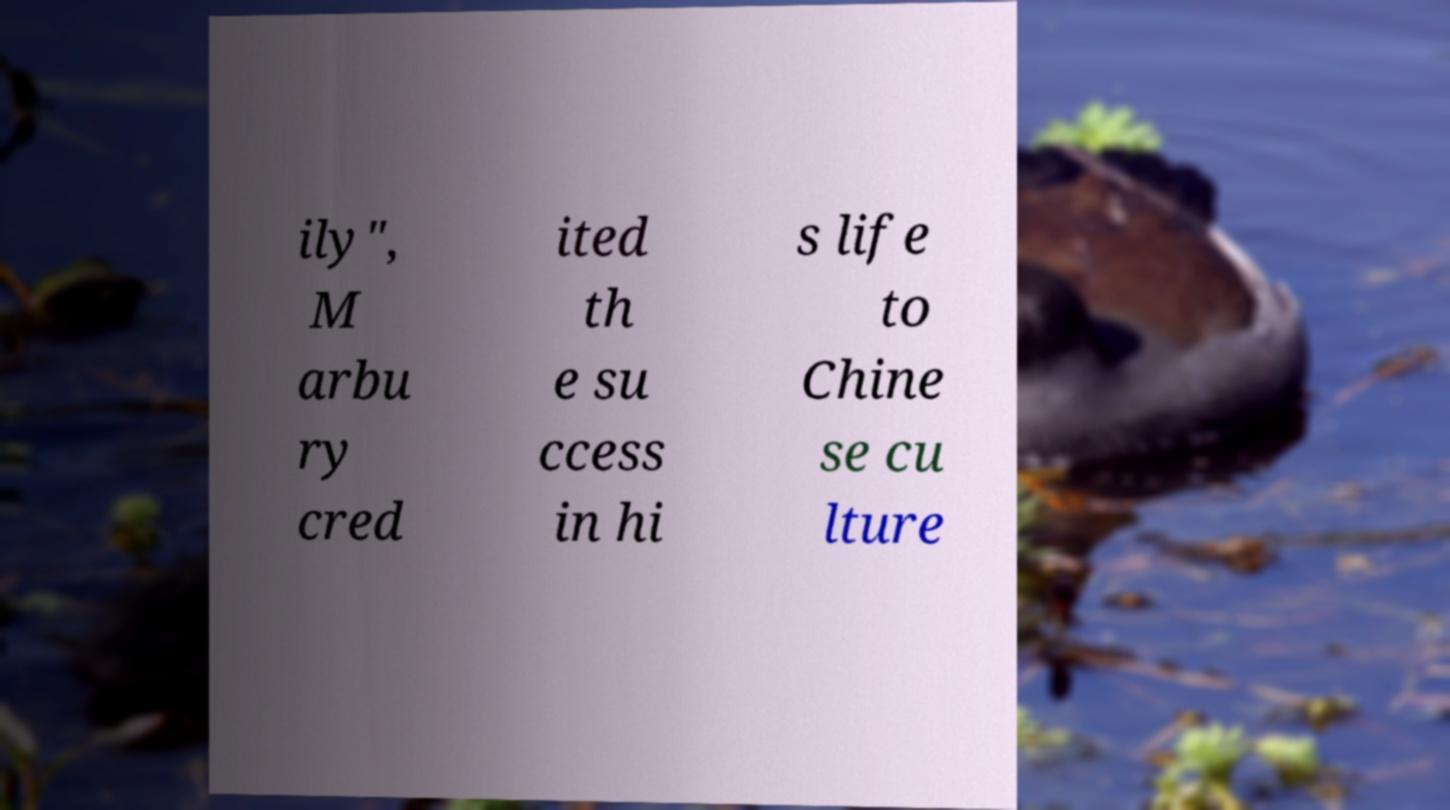Can you read and provide the text displayed in the image?This photo seems to have some interesting text. Can you extract and type it out for me? ily", M arbu ry cred ited th e su ccess in hi s life to Chine se cu lture 